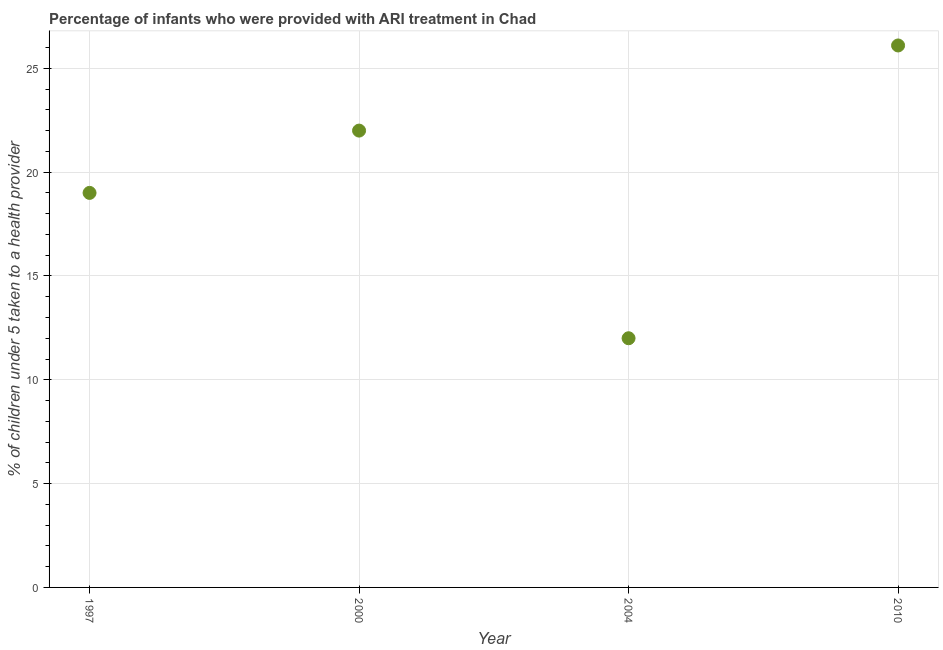What is the percentage of children who were provided with ari treatment in 2010?
Give a very brief answer. 26.1. Across all years, what is the maximum percentage of children who were provided with ari treatment?
Give a very brief answer. 26.1. Across all years, what is the minimum percentage of children who were provided with ari treatment?
Provide a succinct answer. 12. In which year was the percentage of children who were provided with ari treatment maximum?
Your response must be concise. 2010. In which year was the percentage of children who were provided with ari treatment minimum?
Ensure brevity in your answer.  2004. What is the sum of the percentage of children who were provided with ari treatment?
Provide a short and direct response. 79.1. What is the difference between the percentage of children who were provided with ari treatment in 2000 and 2004?
Offer a very short reply. 10. What is the average percentage of children who were provided with ari treatment per year?
Provide a short and direct response. 19.77. What is the median percentage of children who were provided with ari treatment?
Offer a terse response. 20.5. Do a majority of the years between 1997 and 2010 (inclusive) have percentage of children who were provided with ari treatment greater than 1 %?
Offer a terse response. Yes. What is the ratio of the percentage of children who were provided with ari treatment in 1997 to that in 2010?
Give a very brief answer. 0.73. Is the difference between the percentage of children who were provided with ari treatment in 2004 and 2010 greater than the difference between any two years?
Your answer should be compact. Yes. What is the difference between the highest and the second highest percentage of children who were provided with ari treatment?
Your response must be concise. 4.1. Is the sum of the percentage of children who were provided with ari treatment in 1997 and 2000 greater than the maximum percentage of children who were provided with ari treatment across all years?
Your response must be concise. Yes. What is the difference between the highest and the lowest percentage of children who were provided with ari treatment?
Offer a very short reply. 14.1. In how many years, is the percentage of children who were provided with ari treatment greater than the average percentage of children who were provided with ari treatment taken over all years?
Provide a short and direct response. 2. How many years are there in the graph?
Keep it short and to the point. 4. What is the difference between two consecutive major ticks on the Y-axis?
Give a very brief answer. 5. Are the values on the major ticks of Y-axis written in scientific E-notation?
Ensure brevity in your answer.  No. Does the graph contain grids?
Offer a very short reply. Yes. What is the title of the graph?
Keep it short and to the point. Percentage of infants who were provided with ARI treatment in Chad. What is the label or title of the X-axis?
Keep it short and to the point. Year. What is the label or title of the Y-axis?
Your answer should be very brief. % of children under 5 taken to a health provider. What is the % of children under 5 taken to a health provider in 2000?
Provide a short and direct response. 22. What is the % of children under 5 taken to a health provider in 2004?
Ensure brevity in your answer.  12. What is the % of children under 5 taken to a health provider in 2010?
Your answer should be compact. 26.1. What is the difference between the % of children under 5 taken to a health provider in 1997 and 2000?
Provide a short and direct response. -3. What is the difference between the % of children under 5 taken to a health provider in 1997 and 2004?
Provide a succinct answer. 7. What is the difference between the % of children under 5 taken to a health provider in 1997 and 2010?
Give a very brief answer. -7.1. What is the difference between the % of children under 5 taken to a health provider in 2000 and 2010?
Your response must be concise. -4.1. What is the difference between the % of children under 5 taken to a health provider in 2004 and 2010?
Your response must be concise. -14.1. What is the ratio of the % of children under 5 taken to a health provider in 1997 to that in 2000?
Offer a terse response. 0.86. What is the ratio of the % of children under 5 taken to a health provider in 1997 to that in 2004?
Your answer should be very brief. 1.58. What is the ratio of the % of children under 5 taken to a health provider in 1997 to that in 2010?
Provide a short and direct response. 0.73. What is the ratio of the % of children under 5 taken to a health provider in 2000 to that in 2004?
Your answer should be very brief. 1.83. What is the ratio of the % of children under 5 taken to a health provider in 2000 to that in 2010?
Provide a short and direct response. 0.84. What is the ratio of the % of children under 5 taken to a health provider in 2004 to that in 2010?
Keep it short and to the point. 0.46. 